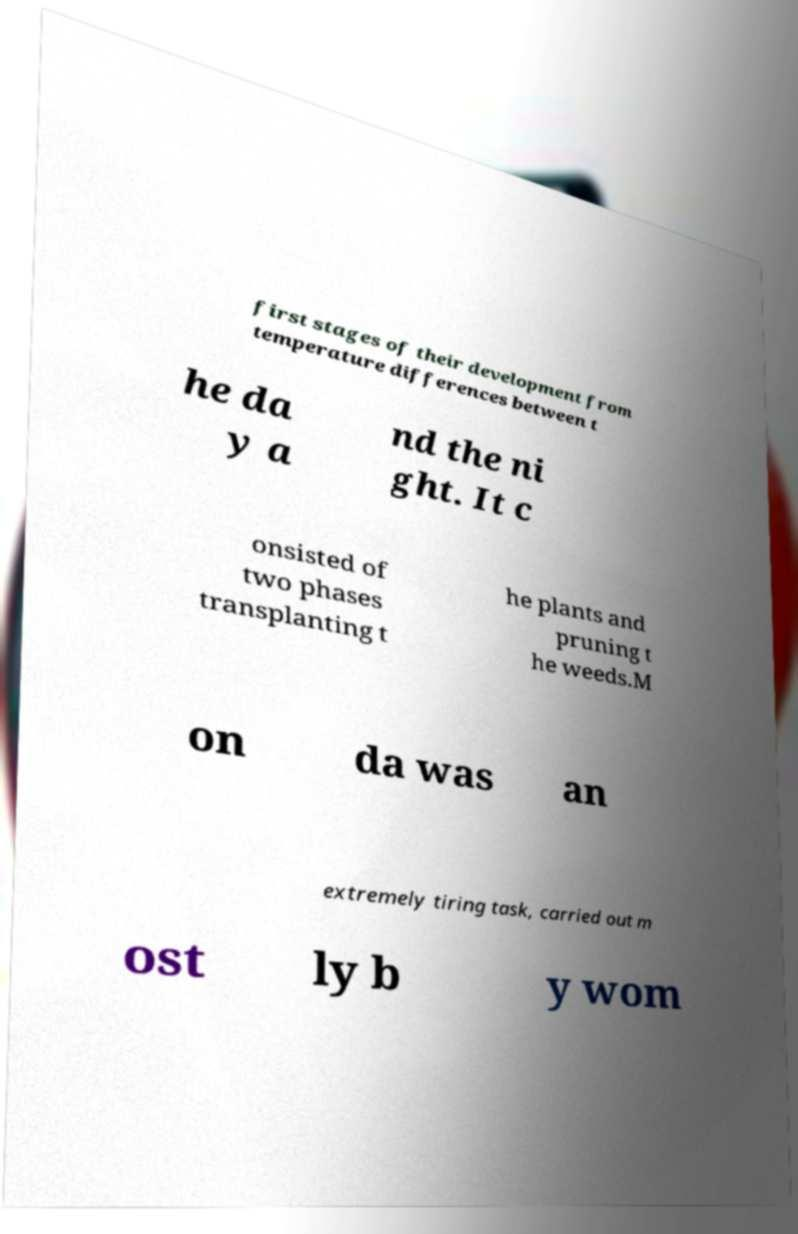Can you accurately transcribe the text from the provided image for me? first stages of their development from temperature differences between t he da y a nd the ni ght. It c onsisted of two phases transplanting t he plants and pruning t he weeds.M on da was an extremely tiring task, carried out m ost ly b y wom 